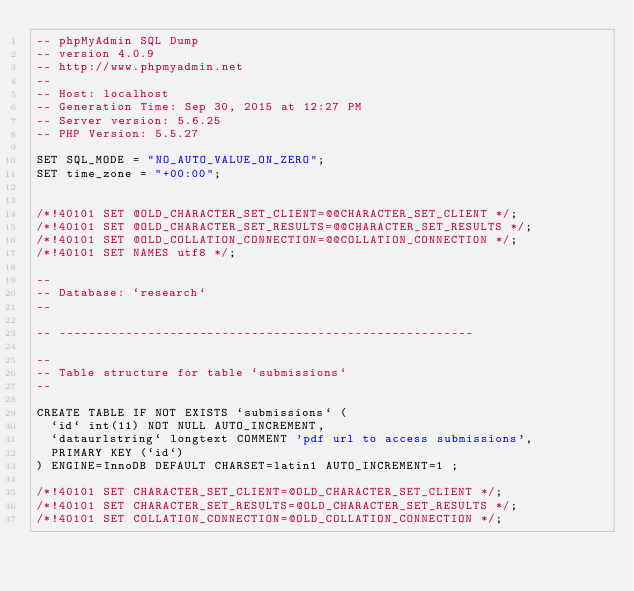<code> <loc_0><loc_0><loc_500><loc_500><_SQL_>-- phpMyAdmin SQL Dump
-- version 4.0.9
-- http://www.phpmyadmin.net
--
-- Host: localhost
-- Generation Time: Sep 30, 2015 at 12:27 PM
-- Server version: 5.6.25
-- PHP Version: 5.5.27

SET SQL_MODE = "NO_AUTO_VALUE_ON_ZERO";
SET time_zone = "+00:00";


/*!40101 SET @OLD_CHARACTER_SET_CLIENT=@@CHARACTER_SET_CLIENT */;
/*!40101 SET @OLD_CHARACTER_SET_RESULTS=@@CHARACTER_SET_RESULTS */;
/*!40101 SET @OLD_COLLATION_CONNECTION=@@COLLATION_CONNECTION */;
/*!40101 SET NAMES utf8 */;

--
-- Database: `research`
--

-- --------------------------------------------------------

--
-- Table structure for table `submissions`
--

CREATE TABLE IF NOT EXISTS `submissions` (
  `id` int(11) NOT NULL AUTO_INCREMENT,
  `dataurlstring` longtext COMMENT 'pdf url to access submissions',
  PRIMARY KEY (`id`)
) ENGINE=InnoDB DEFAULT CHARSET=latin1 AUTO_INCREMENT=1 ;

/*!40101 SET CHARACTER_SET_CLIENT=@OLD_CHARACTER_SET_CLIENT */;
/*!40101 SET CHARACTER_SET_RESULTS=@OLD_CHARACTER_SET_RESULTS */;
/*!40101 SET COLLATION_CONNECTION=@OLD_COLLATION_CONNECTION */;
</code> 